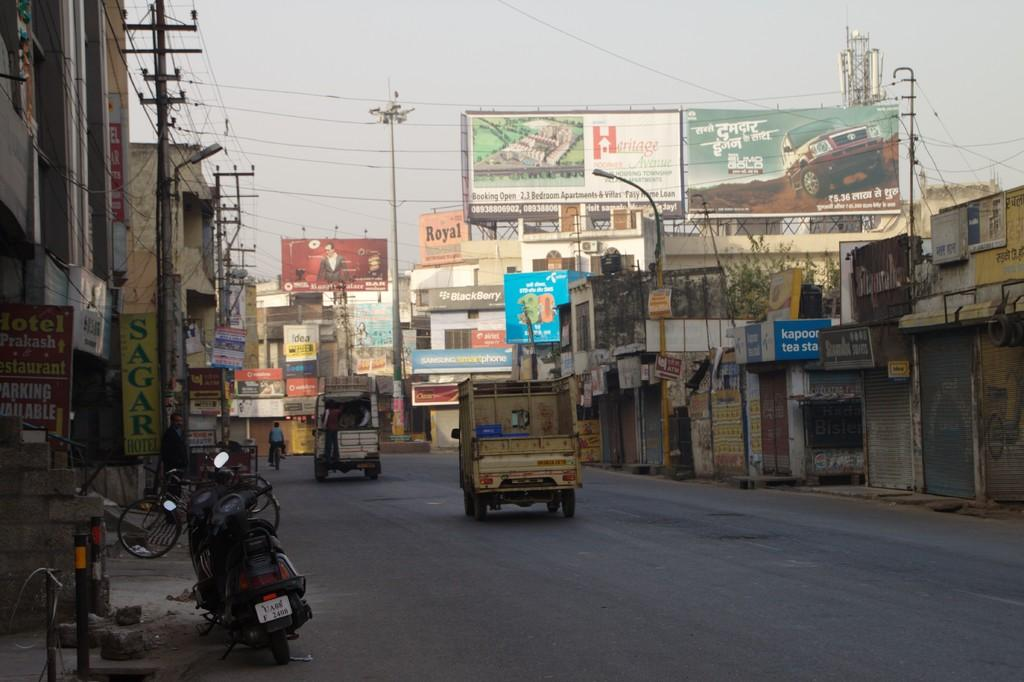What is happening on the road in the image? There are vehicles on the road in the image. What can be seen beside the road? There are buildings beside the road. What objects are present in the image that are not vehicles or buildings? There are poles and name boards in the image. What is visible in the background of the image? The sky is visible in the background of the image. What type of collar can be seen on the creature in the image? There is no creature or collar present in the image. What kind of produce is being sold at the roadside in the image? There is no produce being sold in the image; it features vehicles, buildings, poles, and name boards. 